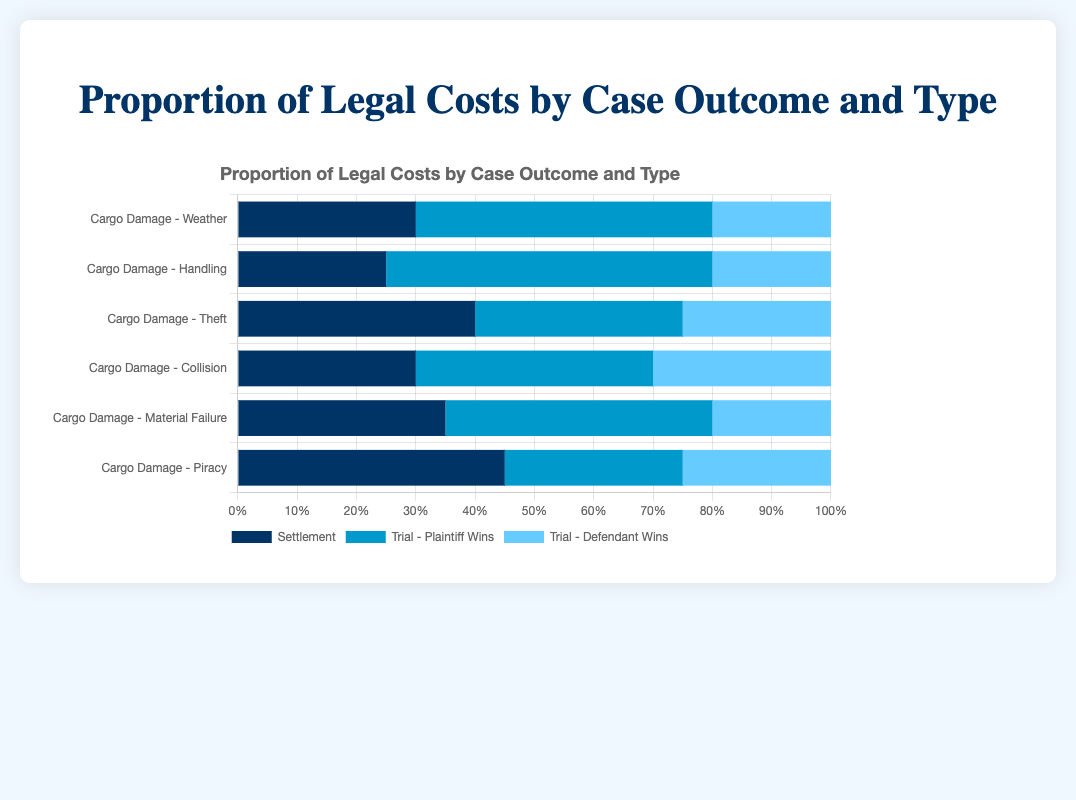Which case type has the highest proportion of legal costs settled out of court? To find the case type with the highest proportion of legal costs settled out of court, look for the bar segment labeled "Settlement" that is the longest. For "Cargo Damage - Piracy," the Settlement proportion is 0.45, which is the highest among all case types.
Answer: Cargo Damage - Piracy Which case type has the lowest proportion of legal costs for "Trial - Defendant Wins"? To determine the case type with the lowest proportion of legal costs for "Trial - Defendant Wins," identify the smallest bar segment labeled "Trial - Defendant Wins." Both "Cargo Damage - Weather" and "Cargo Damage - Handling" have the lowest at 0.2.
Answer: Cargo Damage - Weather, Cargo Damage - Handling How many case types have higher "Settlement" proportions than "Trial - Defendant Wins"? Count the case types where the "Settlement" proportion is greater than the "Trial - Defendant Wins" proportion. This happens in "Cargo Damage - Weather," "Cargo Damage - Handling," "Cargo Damage - Theft," "Cargo Damage - Material Failure," and "Cargo Damage - Piracy." Thus, there are 5 case types.
Answer: 5 What is the sum of proportions for "Cargo Damage - Collision"? Add the "Settlement" (0.3), "Trial - Plaintiff Wins" (0.4), and "Trial - Defendant Wins" (0.3) proportions for "Cargo Damage - Collision." The sum is 0.3 + 0.4 + 0.3 = 1.0.
Answer: 1.0 Which case type has a higher proportion of "Trial - Plaintiff Wins," "Cargo Damage - Handling" or "Cargo Damage - Material Failure"? Compare the proportions of "Trial - Plaintiff Wins" for "Cargo Damage - Handling" (0.55) and "Cargo Damage - Material Failure" (0.45). "Cargo Damage - Handling" has a higher proportion.
Answer: Cargo Damage - Handling If you add the settlement proportions of "Cargo Damage - Weather" and "Cargo Damage - Piracy," what is the result? Add the "Settlement" proportions of "Cargo Damage - Weather" (0.3) and "Cargo Damage - Piracy" (0.45). The result is 0.3 + 0.45 = 0.75.
Answer: 0.75 What is the difference between the length of the "Trial - Defendant Wins" bar for "Cargo Damage - Theft" and "Cargo Damage - Material Failure"? Subtract the proportion of "Trial - Defendant Wins" for "Cargo Damage - Material Failure" (0.2) from "Cargo Damage - Theft" (0.25). The result is 0.25 - 0.2 = 0.05.
Answer: 0.05 